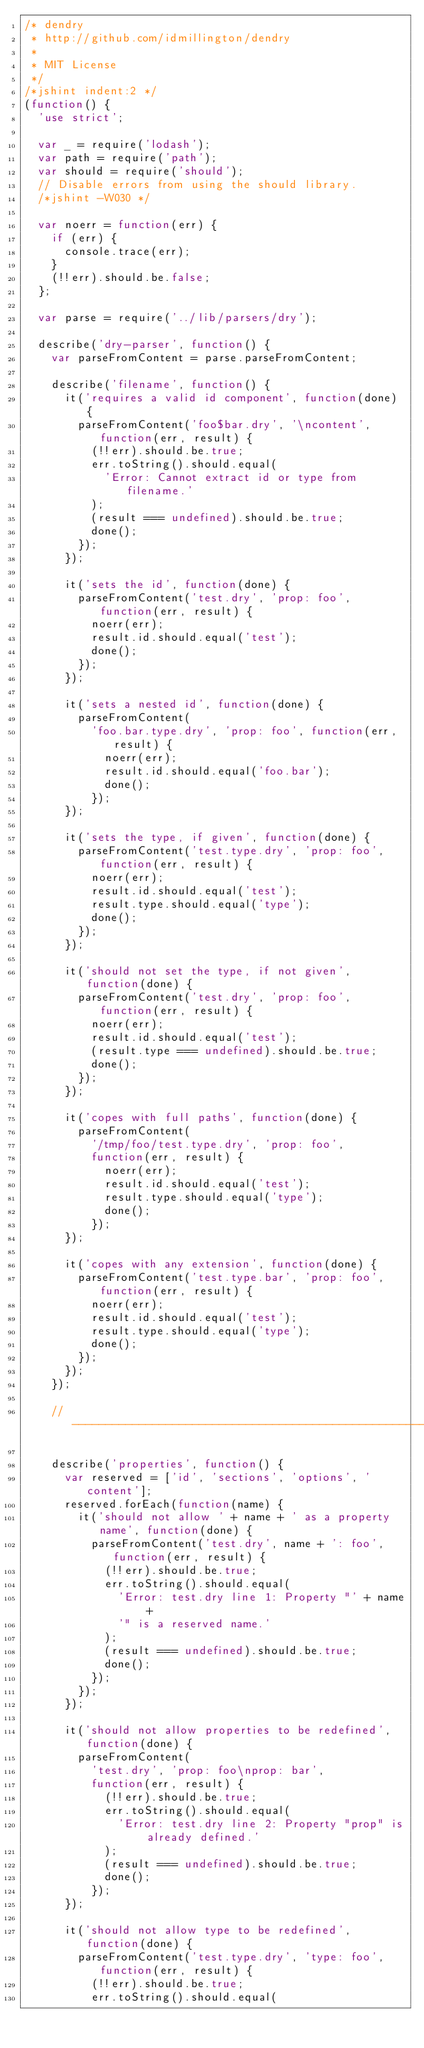<code> <loc_0><loc_0><loc_500><loc_500><_JavaScript_>/* dendry
 * http://github.com/idmillington/dendry
 *
 * MIT License
 */
/*jshint indent:2 */
(function() {
  'use strict';

  var _ = require('lodash');
  var path = require('path');
  var should = require('should');
  // Disable errors from using the should library.
  /*jshint -W030 */

  var noerr = function(err) {
    if (err) {
      console.trace(err);
    }
    (!!err).should.be.false;
  };

  var parse = require('../lib/parsers/dry');

  describe('dry-parser', function() {
    var parseFromContent = parse.parseFromContent;

    describe('filename', function() {
      it('requires a valid id component', function(done) {
        parseFromContent('foo$bar.dry', '\ncontent', function(err, result) {
          (!!err).should.be.true;
          err.toString().should.equal(
            'Error: Cannot extract id or type from filename.'
          );
          (result === undefined).should.be.true;
          done();
        });
      });

      it('sets the id', function(done) {
        parseFromContent('test.dry', 'prop: foo', function(err, result) {
          noerr(err);
          result.id.should.equal('test');
          done();
        });
      });

      it('sets a nested id', function(done) {
        parseFromContent(
          'foo.bar.type.dry', 'prop: foo', function(err, result) {
            noerr(err);
            result.id.should.equal('foo.bar');
            done();
          });
      });

      it('sets the type, if given', function(done) {
        parseFromContent('test.type.dry', 'prop: foo', function(err, result) {
          noerr(err);
          result.id.should.equal('test');
          result.type.should.equal('type');
          done();
        });
      });

      it('should not set the type, if not given', function(done) {
        parseFromContent('test.dry', 'prop: foo', function(err, result) {
          noerr(err);
          result.id.should.equal('test');
          (result.type === undefined).should.be.true;
          done();
        });
      });

      it('copes with full paths', function(done) {
        parseFromContent(
          '/tmp/foo/test.type.dry', 'prop: foo',
          function(err, result) {
            noerr(err);
            result.id.should.equal('test');
            result.type.should.equal('type');
            done();
          });
      });

      it('copes with any extension', function(done) {
        parseFromContent('test.type.bar', 'prop: foo', function(err, result) {
          noerr(err);
          result.id.should.equal('test');
          result.type.should.equal('type');
          done();
        });
      });
    });

    // ----------------------------------------------------------------------

    describe('properties', function() {
      var reserved = ['id', 'sections', 'options', 'content'];
      reserved.forEach(function(name) {
        it('should not allow ' + name + ' as a property name', function(done) {
          parseFromContent('test.dry', name + ': foo', function(err, result) {
            (!!err).should.be.true;
            err.toString().should.equal(
              'Error: test.dry line 1: Property "' + name +
              '" is a reserved name.'
            );
            (result === undefined).should.be.true;
            done();
          });
        });
      });

      it('should not allow properties to be redefined', function(done) {
        parseFromContent(
          'test.dry', 'prop: foo\nprop: bar',
          function(err, result) {
            (!!err).should.be.true;
            err.toString().should.equal(
              'Error: test.dry line 2: Property "prop" is already defined.'
            );
            (result === undefined).should.be.true;
            done();
          });
      });

      it('should not allow type to be redefined', function(done) {
        parseFromContent('test.type.dry', 'type: foo', function(err, result) {
          (!!err).should.be.true;
          err.toString().should.equal(</code> 